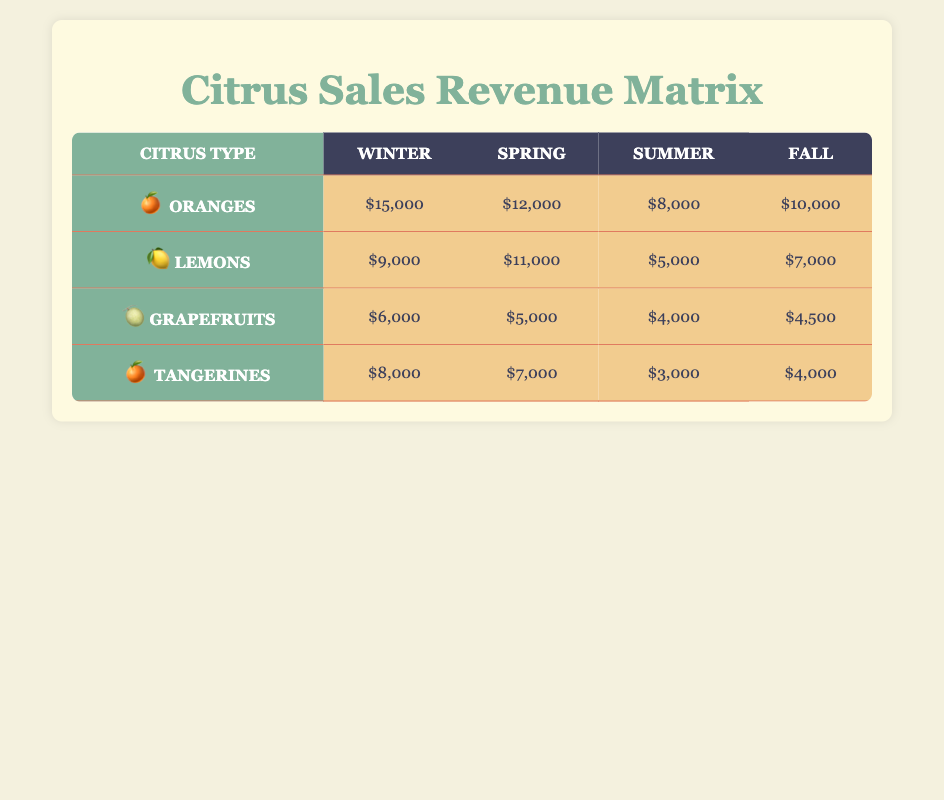What is the revenue from Oranges in the Winter season? According to the table, the revenue listed for Oranges during the Winter season is $15,000.
Answer: $15,000 Which citrus type had the highest revenue in Spring? By examining the table, the revenues in Spring are: Oranges ($12,000), Lemons ($11,000), Grapefruits ($5,000), and Tangerines ($7,000). Oranges have the highest revenue at $12,000.
Answer: Oranges What is the average revenue for Grapefruits across all seasons? The revenues for Grapefruits are: Winter ($6,000), Spring ($5,000), Summer ($4,000), and Fall ($4,500). Summing these gives $6,000 + $5,000 + $4,000 + $4,500 = $19,500. The average is $19,500 divided by 4 seasons, which equals $4,875.
Answer: $4,875 Did Lemons generate more revenue in Spring than Tangerines? In the Spring, Lemons generated $11,000, while Tangerines generated $7,000. Since $11,000 is greater than $7,000, the statement is true.
Answer: Yes What is the total revenue from all citrus types in Summer? From the table, the Summer revenues are: Oranges ($8,000), Lemons ($5,000), Grapefruits ($4,000), and Tangerines ($3,000). Adding these gives a total of $8,000 + $5,000 + $4,000 + $3,000 = $20,000.
Answer: $20,000 Is it true that Tangerines had their highest revenue in Fall? The revenue for Tangerines in Fall is $4,000. In Winter, they had $8,000; in Spring, $7,000; and in Summer, $3,000. Since the highest revenue was in Winter, the statement is false.
Answer: No Which season had the lowest overall revenue for all citrus types? To determine this, we examine each season's total revenue: Winter ($15,000 + $9,000 + $6,000 + $8,000 = $38,000), Spring ($12,000 + $11,000 + $5,000 + $7,000 = $35,000), Summer ($8,000 + $5,000 + $4,000 + $3,000 = $20,000), and Fall ($10,000 + $7,000 + $4,500 + $4,000 = $25,500). The lowest total revenue is in Summer at $20,000.
Answer: Summer What is the difference in revenue between Lemons in Spring and in Fall? Lemons generated $11,000 in Spring and $7,000 in Fall. The difference is obtained by subtracting Fall revenue from Spring revenue: $11,000 - $7,000 = $4,000.
Answer: $4,000 Which citrus type had the least revenue in Summer? Analyzing the Summer revenues: Oranges ($8,000), Lemons ($5,000), Grapefruits ($4,000), and Tangerines ($3,000). The least revenue is from Tangerines at $3,000.
Answer: Tangerines 